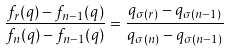Convert formula to latex. <formula><loc_0><loc_0><loc_500><loc_500>\frac { f _ { r } ( q ) - f _ { n - 1 } ( q ) } { f _ { n } ( q ) - f _ { n - 1 } ( q ) } = \frac { q _ { \sigma ( r ) } - q _ { \sigma ( n - 1 ) } } { q _ { \sigma ( n ) } - q _ { \sigma ( n - 1 ) } }</formula> 